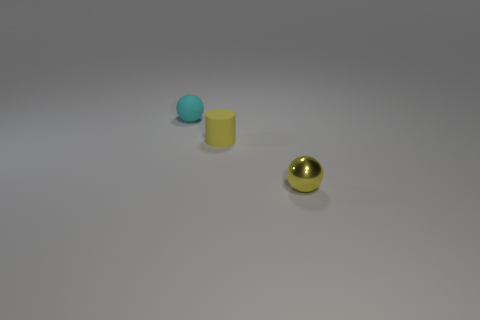Subtract 1 spheres. How many spheres are left? 1 Subtract all cylinders. How many objects are left? 2 Subtract all yellow spheres. How many spheres are left? 1 Add 1 balls. How many balls are left? 3 Add 2 large gray rubber cylinders. How many large gray rubber cylinders exist? 2 Add 2 tiny rubber spheres. How many objects exist? 5 Subtract 0 blue balls. How many objects are left? 3 Subtract all gray spheres. Subtract all cyan blocks. How many spheres are left? 2 Subtract all purple blocks. How many yellow spheres are left? 1 Subtract all gray balls. Subtract all rubber balls. How many objects are left? 2 